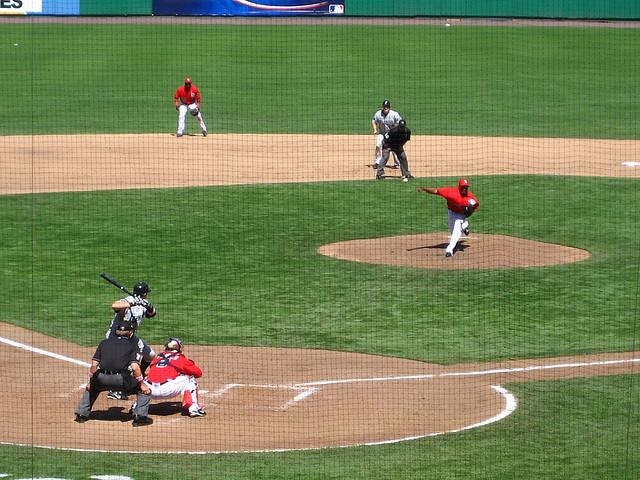Is there someone standing on second base?
Concise answer only. No. Has the batter hit the ball yet?
Keep it brief. No. Can you see the shortstop?
Concise answer only. Yes. Where was it taken?
Write a very short answer. Baseball game. What sport are these people playing?
Give a very brief answer. Baseball. 